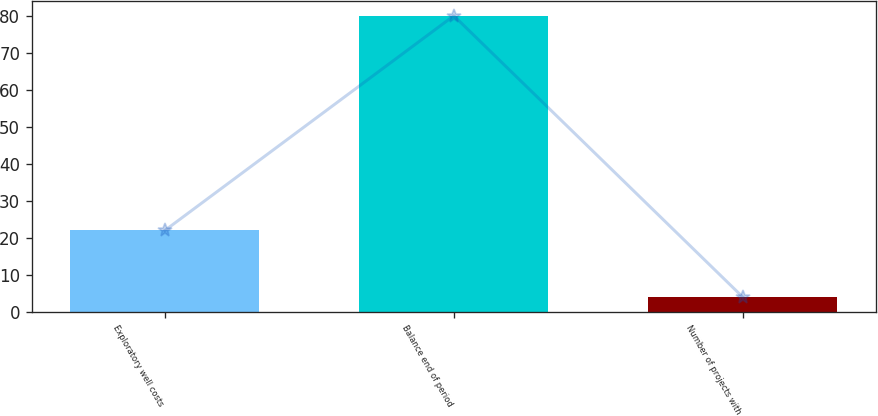<chart> <loc_0><loc_0><loc_500><loc_500><bar_chart><fcel>Exploratory well costs<fcel>Balance end of period<fcel>Number of projects with<nl><fcel>22<fcel>80<fcel>4<nl></chart> 